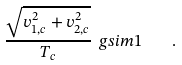<formula> <loc_0><loc_0><loc_500><loc_500>\frac { \sqrt { v _ { 1 , c } ^ { 2 } + v _ { 2 , c } ^ { 2 } } } { T _ { c } } \ g s i m 1 \quad .</formula> 